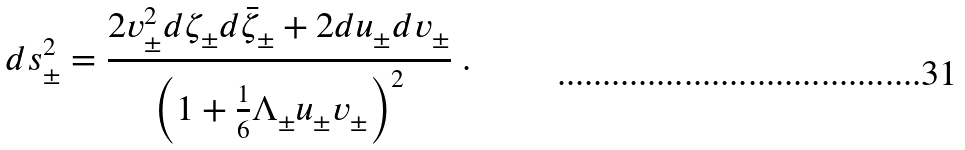<formula> <loc_0><loc_0><loc_500><loc_500>d s ^ { 2 } _ { \pm } = \frac { 2 v ^ { 2 } _ { \pm } d \zeta _ { \pm } d \bar { \zeta } _ { \pm } + 2 d u _ { \pm } d v _ { \pm } } { \left ( 1 + \frac { 1 } { 6 } \Lambda _ { \pm } u _ { \pm } v _ { \pm } \right ) ^ { 2 } } \ .</formula> 